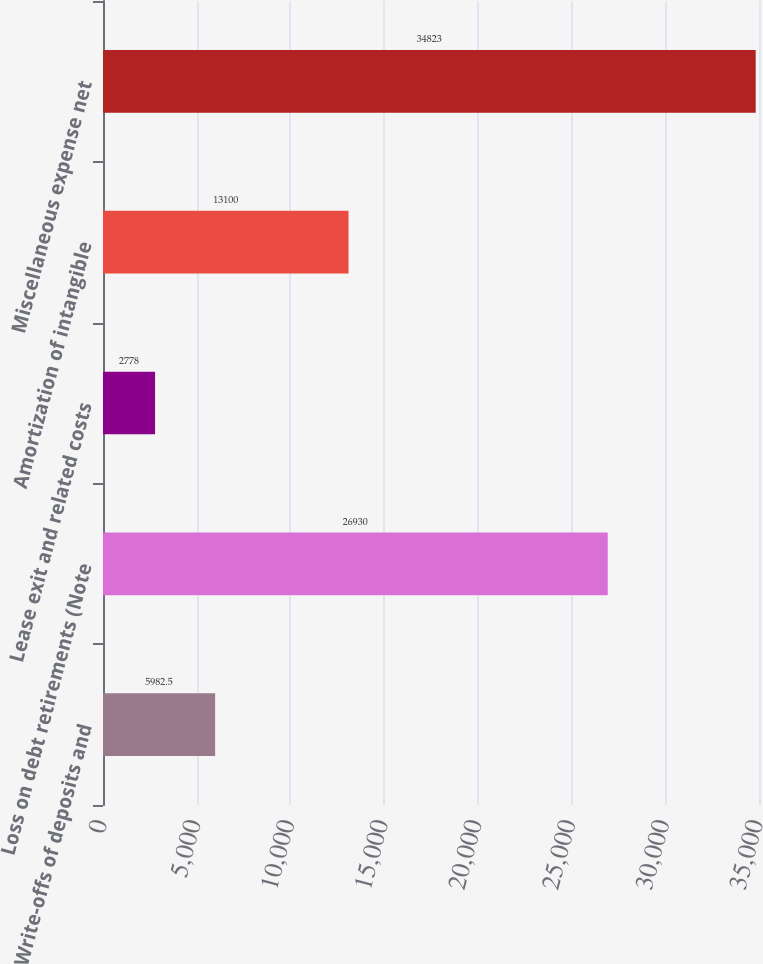<chart> <loc_0><loc_0><loc_500><loc_500><bar_chart><fcel>Write-offs of deposits and<fcel>Loss on debt retirements (Note<fcel>Lease exit and related costs<fcel>Amortization of intangible<fcel>Miscellaneous expense net<nl><fcel>5982.5<fcel>26930<fcel>2778<fcel>13100<fcel>34823<nl></chart> 